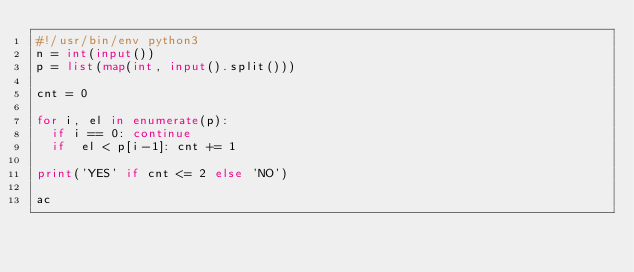Convert code to text. <code><loc_0><loc_0><loc_500><loc_500><_Python_>#!/usr/bin/env python3
n = int(input())
p = list(map(int, input().split()))

cnt = 0

for i, el in enumerate(p):
  if i == 0: continue
  if  el < p[i-1]: cnt += 1

print('YES' if cnt <= 2 else 'NO')

ac</code> 